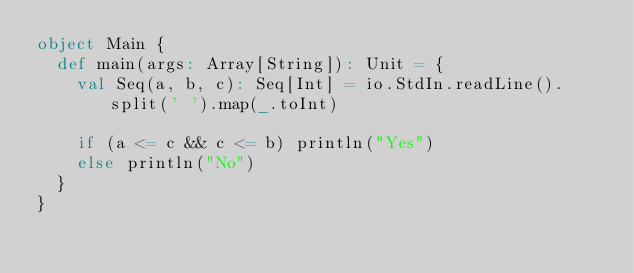Convert code to text. <code><loc_0><loc_0><loc_500><loc_500><_Scala_>object Main {
  def main(args: Array[String]): Unit = {
    val Seq(a, b, c): Seq[Int] = io.StdIn.readLine().split(' ').map(_.toInt)

    if (a <= c && c <= b) println("Yes")
    else println("No")
  }
}</code> 